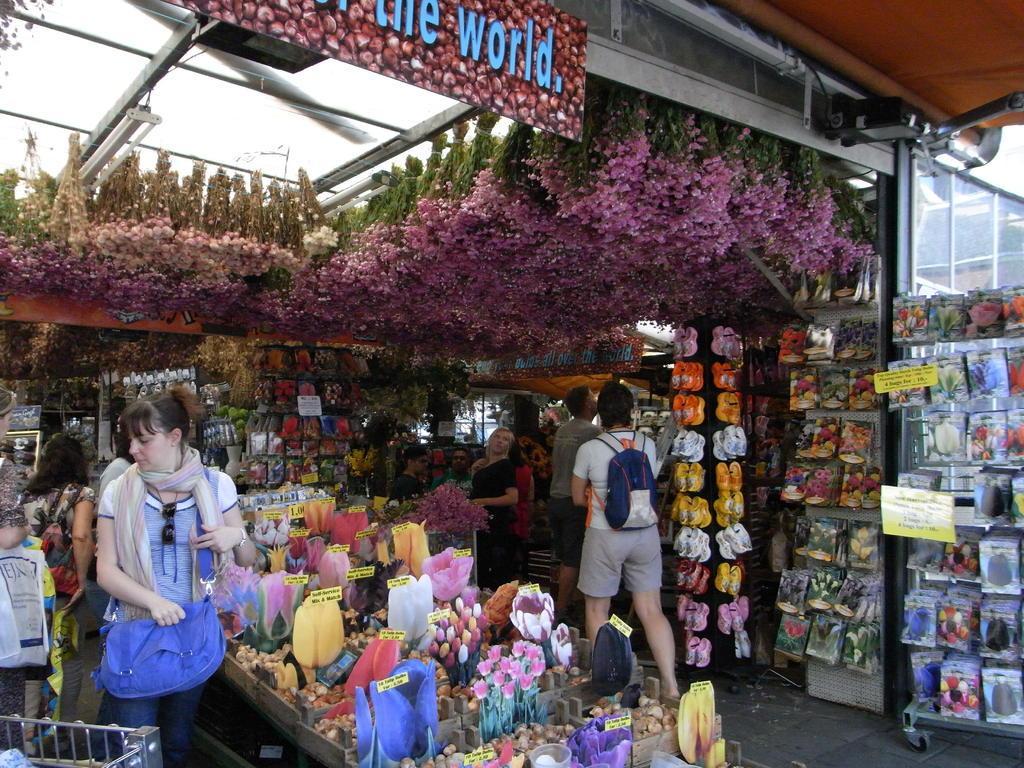Describe this image in one or two sentences. Here it is looking like a stall. On the tables I can see many objects like flowers, fruits boards and some more. There are few people standing and looking at the products. On the right side, I can see few packets are hanging to a board. On the top of the image I can see few flowers along with the plants and also there is a board on which I can see some text. 